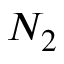<formula> <loc_0><loc_0><loc_500><loc_500>N _ { 2 }</formula> 